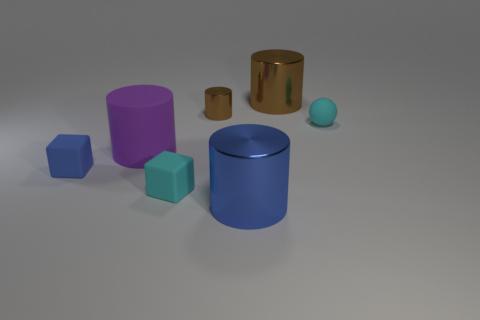The block that is the same color as the tiny sphere is what size?
Your answer should be very brief. Small. There is a large thing in front of the cyan object in front of the small blue rubber block; what is it made of?
Ensure brevity in your answer.  Metal. The matte thing that is the same shape as the tiny metallic object is what color?
Provide a short and direct response. Purple. Is the small brown object made of the same material as the big thing that is behind the sphere?
Offer a terse response. Yes. What is the shape of the blue object behind the cyan thing left of the small cylinder?
Offer a very short reply. Cube. Do the cyan rubber thing to the left of the sphere and the blue rubber thing have the same size?
Provide a succinct answer. Yes. What number of other objects are there of the same shape as the big purple thing?
Offer a terse response. 3. There is a big cylinder right of the blue metallic thing; does it have the same color as the small cylinder?
Provide a short and direct response. Yes. Are there any blocks that have the same color as the ball?
Provide a short and direct response. Yes. There is a tiny cyan block; how many spheres are right of it?
Offer a terse response. 1. 